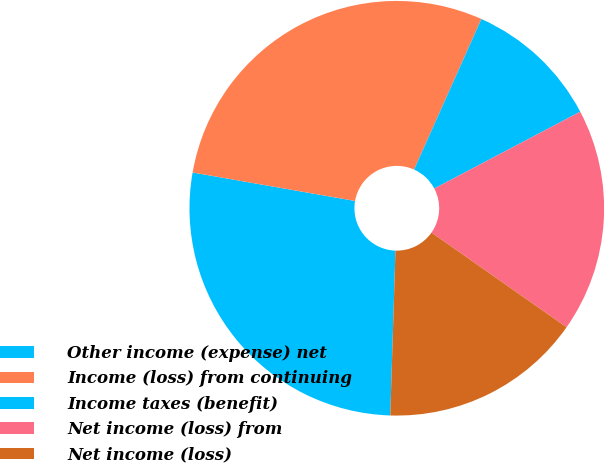Convert chart. <chart><loc_0><loc_0><loc_500><loc_500><pie_chart><fcel>Other income (expense) net<fcel>Income (loss) from continuing<fcel>Income taxes (benefit)<fcel>Net income (loss) from<fcel>Net income (loss)<nl><fcel>27.26%<fcel>28.93%<fcel>10.6%<fcel>17.44%<fcel>15.77%<nl></chart> 